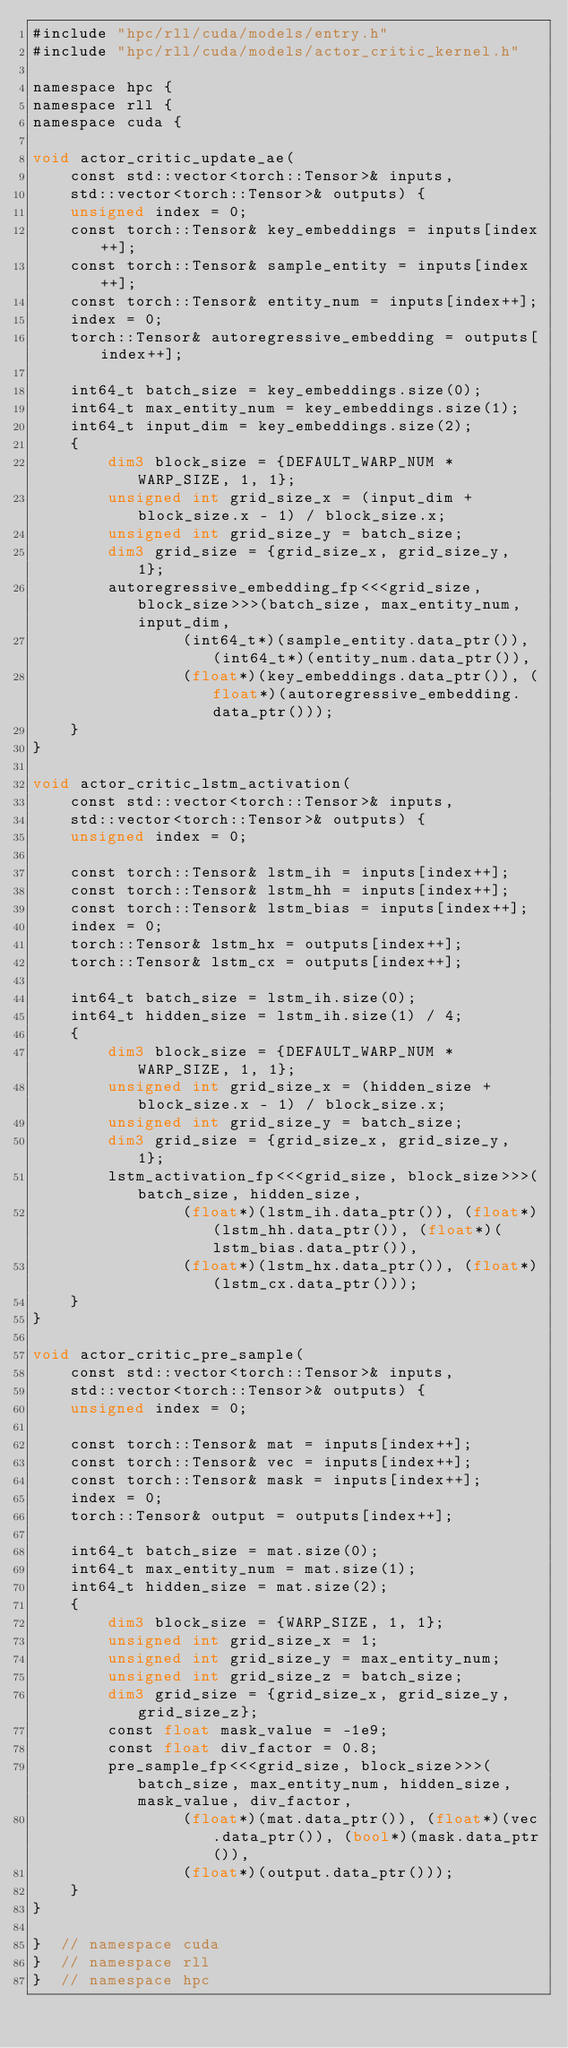Convert code to text. <code><loc_0><loc_0><loc_500><loc_500><_Cuda_>#include "hpc/rll/cuda/models/entry.h"
#include "hpc/rll/cuda/models/actor_critic_kernel.h"

namespace hpc {
namespace rll {
namespace cuda {

void actor_critic_update_ae(
    const std::vector<torch::Tensor>& inputs,
    std::vector<torch::Tensor>& outputs) {
    unsigned index = 0;
    const torch::Tensor& key_embeddings = inputs[index++];
    const torch::Tensor& sample_entity = inputs[index++];
    const torch::Tensor& entity_num = inputs[index++];
    index = 0;
    torch::Tensor& autoregressive_embedding = outputs[index++];

    int64_t batch_size = key_embeddings.size(0);
    int64_t max_entity_num = key_embeddings.size(1);
    int64_t input_dim = key_embeddings.size(2);
    {
        dim3 block_size = {DEFAULT_WARP_NUM * WARP_SIZE, 1, 1};
        unsigned int grid_size_x = (input_dim + block_size.x - 1) / block_size.x;
        unsigned int grid_size_y = batch_size;
        dim3 grid_size = {grid_size_x, grid_size_y, 1};
        autoregressive_embedding_fp<<<grid_size, block_size>>>(batch_size, max_entity_num, input_dim,
                (int64_t*)(sample_entity.data_ptr()), (int64_t*)(entity_num.data_ptr()),
                (float*)(key_embeddings.data_ptr()), (float*)(autoregressive_embedding.data_ptr()));
    }
}

void actor_critic_lstm_activation(
    const std::vector<torch::Tensor>& inputs,
    std::vector<torch::Tensor>& outputs) {
    unsigned index = 0;

    const torch::Tensor& lstm_ih = inputs[index++];
    const torch::Tensor& lstm_hh = inputs[index++];
    const torch::Tensor& lstm_bias = inputs[index++];
    index = 0;
    torch::Tensor& lstm_hx = outputs[index++];
    torch::Tensor& lstm_cx = outputs[index++];

    int64_t batch_size = lstm_ih.size(0);
    int64_t hidden_size = lstm_ih.size(1) / 4;
    {
        dim3 block_size = {DEFAULT_WARP_NUM * WARP_SIZE, 1, 1};
        unsigned int grid_size_x = (hidden_size + block_size.x - 1) / block_size.x;
        unsigned int grid_size_y = batch_size;
        dim3 grid_size = {grid_size_x, grid_size_y, 1};
        lstm_activation_fp<<<grid_size, block_size>>>(batch_size, hidden_size,
                (float*)(lstm_ih.data_ptr()), (float*)(lstm_hh.data_ptr()), (float*)(lstm_bias.data_ptr()),
                (float*)(lstm_hx.data_ptr()), (float*)(lstm_cx.data_ptr()));
    }
}

void actor_critic_pre_sample(
    const std::vector<torch::Tensor>& inputs,
    std::vector<torch::Tensor>& outputs) {
    unsigned index = 0;

    const torch::Tensor& mat = inputs[index++];
    const torch::Tensor& vec = inputs[index++];
    const torch::Tensor& mask = inputs[index++];
    index = 0;
    torch::Tensor& output = outputs[index++];

    int64_t batch_size = mat.size(0);
    int64_t max_entity_num = mat.size(1);
    int64_t hidden_size = mat.size(2);
    {
        dim3 block_size = {WARP_SIZE, 1, 1};
        unsigned int grid_size_x = 1;
        unsigned int grid_size_y = max_entity_num;
        unsigned int grid_size_z = batch_size;
        dim3 grid_size = {grid_size_x, grid_size_y, grid_size_z};
        const float mask_value = -1e9;
        const float div_factor = 0.8;
        pre_sample_fp<<<grid_size, block_size>>>(batch_size, max_entity_num, hidden_size, mask_value, div_factor,
                (float*)(mat.data_ptr()), (float*)(vec.data_ptr()), (bool*)(mask.data_ptr()),
                (float*)(output.data_ptr()));
    }
}

}  // namespace cuda
}  // namespace rll
}  // namespace hpc
</code> 